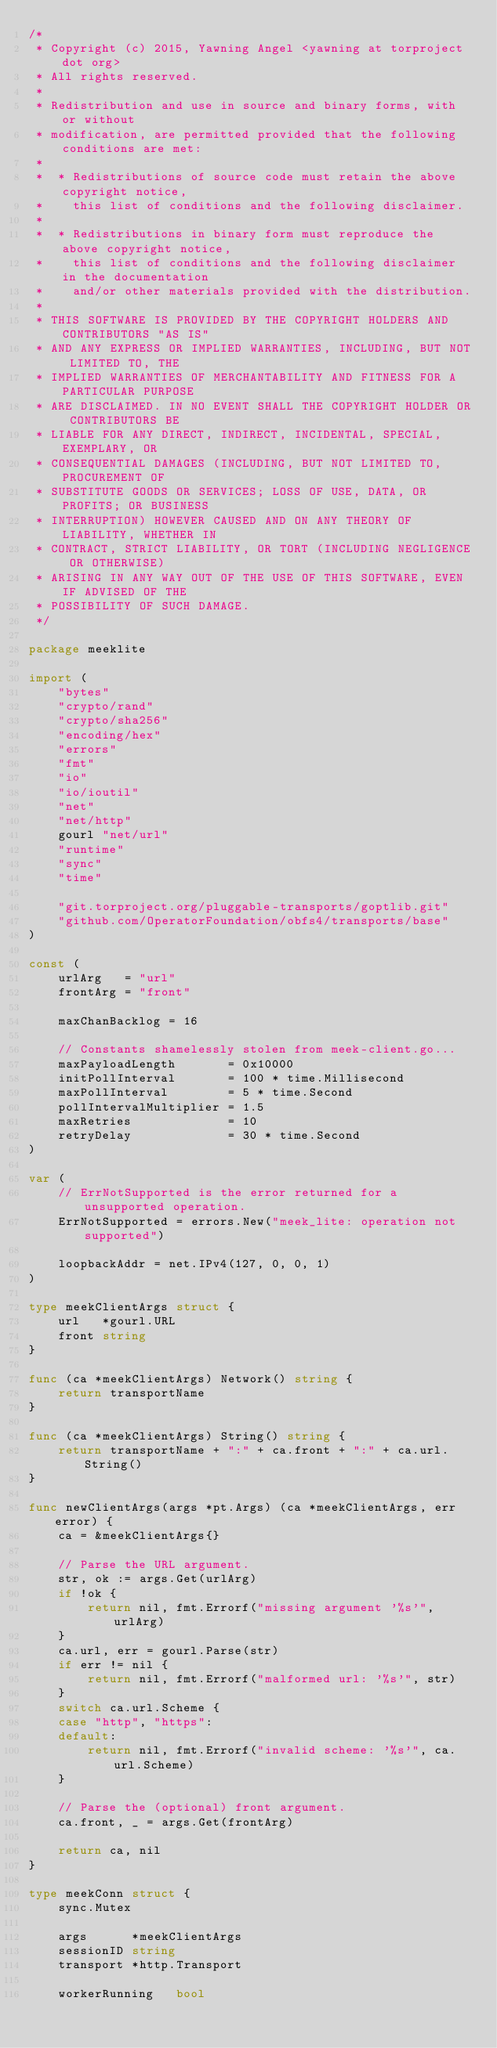<code> <loc_0><loc_0><loc_500><loc_500><_Go_>/*
 * Copyright (c) 2015, Yawning Angel <yawning at torproject dot org>
 * All rights reserved.
 *
 * Redistribution and use in source and binary forms, with or without
 * modification, are permitted provided that the following conditions are met:
 *
 *  * Redistributions of source code must retain the above copyright notice,
 *    this list of conditions and the following disclaimer.
 *
 *  * Redistributions in binary form must reproduce the above copyright notice,
 *    this list of conditions and the following disclaimer in the documentation
 *    and/or other materials provided with the distribution.
 *
 * THIS SOFTWARE IS PROVIDED BY THE COPYRIGHT HOLDERS AND CONTRIBUTORS "AS IS"
 * AND ANY EXPRESS OR IMPLIED WARRANTIES, INCLUDING, BUT NOT LIMITED TO, THE
 * IMPLIED WARRANTIES OF MERCHANTABILITY AND FITNESS FOR A PARTICULAR PURPOSE
 * ARE DISCLAIMED. IN NO EVENT SHALL THE COPYRIGHT HOLDER OR CONTRIBUTORS BE
 * LIABLE FOR ANY DIRECT, INDIRECT, INCIDENTAL, SPECIAL, EXEMPLARY, OR
 * CONSEQUENTIAL DAMAGES (INCLUDING, BUT NOT LIMITED TO, PROCUREMENT OF
 * SUBSTITUTE GOODS OR SERVICES; LOSS OF USE, DATA, OR PROFITS; OR BUSINESS
 * INTERRUPTION) HOWEVER CAUSED AND ON ANY THEORY OF LIABILITY, WHETHER IN
 * CONTRACT, STRICT LIABILITY, OR TORT (INCLUDING NEGLIGENCE OR OTHERWISE)
 * ARISING IN ANY WAY OUT OF THE USE OF THIS SOFTWARE, EVEN IF ADVISED OF THE
 * POSSIBILITY OF SUCH DAMAGE.
 */

package meeklite

import (
	"bytes"
	"crypto/rand"
	"crypto/sha256"
	"encoding/hex"
	"errors"
	"fmt"
	"io"
	"io/ioutil"
	"net"
	"net/http"
	gourl "net/url"
	"runtime"
	"sync"
	"time"

	"git.torproject.org/pluggable-transports/goptlib.git"
	"github.com/OperatorFoundation/obfs4/transports/base"
)

const (
	urlArg   = "url"
	frontArg = "front"

	maxChanBacklog = 16

	// Constants shamelessly stolen from meek-client.go...
	maxPayloadLength       = 0x10000
	initPollInterval       = 100 * time.Millisecond
	maxPollInterval        = 5 * time.Second
	pollIntervalMultiplier = 1.5
	maxRetries             = 10
	retryDelay             = 30 * time.Second
)

var (
	// ErrNotSupported is the error returned for a unsupported operation.
	ErrNotSupported = errors.New("meek_lite: operation not supported")

	loopbackAddr = net.IPv4(127, 0, 0, 1)
)

type meekClientArgs struct {
	url   *gourl.URL
	front string
}

func (ca *meekClientArgs) Network() string {
	return transportName
}

func (ca *meekClientArgs) String() string {
	return transportName + ":" + ca.front + ":" + ca.url.String()
}

func newClientArgs(args *pt.Args) (ca *meekClientArgs, err error) {
	ca = &meekClientArgs{}

	// Parse the URL argument.
	str, ok := args.Get(urlArg)
	if !ok {
		return nil, fmt.Errorf("missing argument '%s'", urlArg)
	}
	ca.url, err = gourl.Parse(str)
	if err != nil {
		return nil, fmt.Errorf("malformed url: '%s'", str)
	}
	switch ca.url.Scheme {
	case "http", "https":
	default:
		return nil, fmt.Errorf("invalid scheme: '%s'", ca.url.Scheme)
	}

	// Parse the (optional) front argument.
	ca.front, _ = args.Get(frontArg)

	return ca, nil
}

type meekConn struct {
	sync.Mutex

	args      *meekClientArgs
	sessionID string
	transport *http.Transport

	workerRunning   bool</code> 